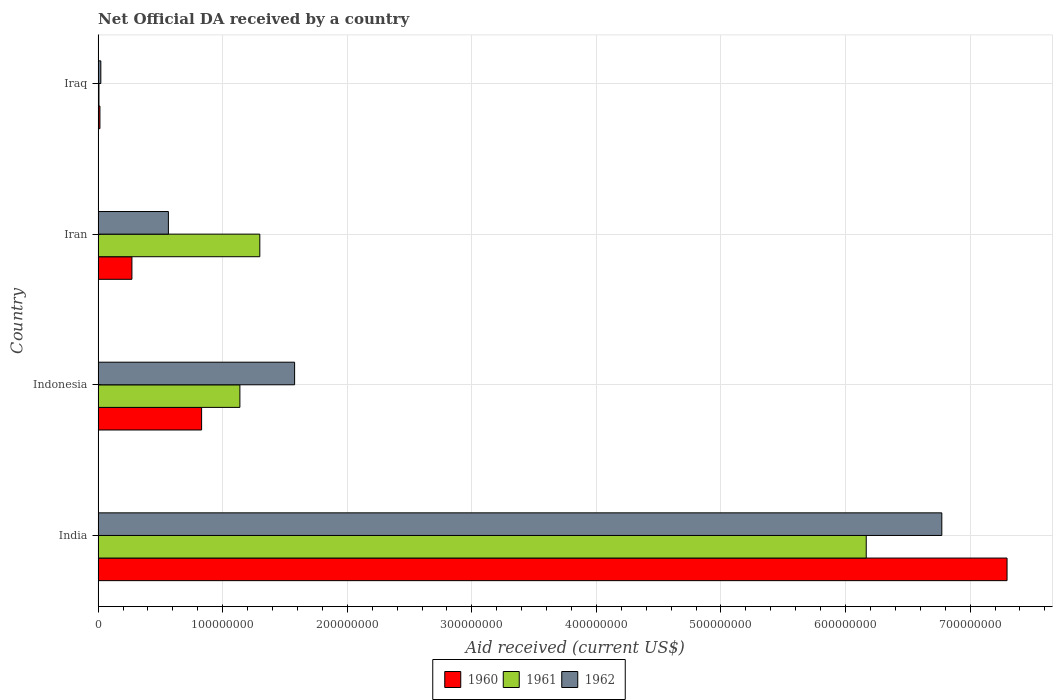How many groups of bars are there?
Offer a terse response. 4. How many bars are there on the 4th tick from the top?
Keep it short and to the point. 3. How many bars are there on the 2nd tick from the bottom?
Provide a succinct answer. 3. What is the label of the 2nd group of bars from the top?
Provide a short and direct response. Iran. What is the net official development assistance aid received in 1962 in Indonesia?
Provide a short and direct response. 1.58e+08. Across all countries, what is the maximum net official development assistance aid received in 1962?
Provide a short and direct response. 6.77e+08. Across all countries, what is the minimum net official development assistance aid received in 1961?
Your response must be concise. 6.80e+05. In which country was the net official development assistance aid received in 1961 minimum?
Offer a terse response. Iraq. What is the total net official development assistance aid received in 1960 in the graph?
Your answer should be compact. 8.41e+08. What is the difference between the net official development assistance aid received in 1961 in Indonesia and that in Iraq?
Keep it short and to the point. 1.13e+08. What is the difference between the net official development assistance aid received in 1960 in Iraq and the net official development assistance aid received in 1962 in Indonesia?
Ensure brevity in your answer.  -1.56e+08. What is the average net official development assistance aid received in 1960 per country?
Provide a short and direct response. 2.10e+08. What is the difference between the net official development assistance aid received in 1962 and net official development assistance aid received in 1961 in Indonesia?
Your answer should be compact. 4.39e+07. In how many countries, is the net official development assistance aid received in 1961 greater than 360000000 US$?
Your answer should be compact. 1. What is the ratio of the net official development assistance aid received in 1960 in Iran to that in Iraq?
Keep it short and to the point. 18.71. Is the net official development assistance aid received in 1961 in India less than that in Indonesia?
Your answer should be very brief. No. What is the difference between the highest and the second highest net official development assistance aid received in 1962?
Provide a short and direct response. 5.20e+08. What is the difference between the highest and the lowest net official development assistance aid received in 1961?
Your answer should be compact. 6.16e+08. What does the 1st bar from the bottom in Iraq represents?
Give a very brief answer. 1960. How many bars are there?
Offer a very short reply. 12. How many countries are there in the graph?
Give a very brief answer. 4. What is the difference between two consecutive major ticks on the X-axis?
Make the answer very short. 1.00e+08. Are the values on the major ticks of X-axis written in scientific E-notation?
Your response must be concise. No. Does the graph contain any zero values?
Make the answer very short. No. Where does the legend appear in the graph?
Make the answer very short. Bottom center. How are the legend labels stacked?
Your response must be concise. Horizontal. What is the title of the graph?
Keep it short and to the point. Net Official DA received by a country. Does "1997" appear as one of the legend labels in the graph?
Your answer should be very brief. No. What is the label or title of the X-axis?
Ensure brevity in your answer.  Aid received (current US$). What is the label or title of the Y-axis?
Offer a very short reply. Country. What is the Aid received (current US$) in 1960 in India?
Your answer should be very brief. 7.30e+08. What is the Aid received (current US$) of 1961 in India?
Keep it short and to the point. 6.17e+08. What is the Aid received (current US$) of 1962 in India?
Your answer should be compact. 6.77e+08. What is the Aid received (current US$) in 1960 in Indonesia?
Ensure brevity in your answer.  8.31e+07. What is the Aid received (current US$) in 1961 in Indonesia?
Offer a very short reply. 1.14e+08. What is the Aid received (current US$) of 1962 in Indonesia?
Your response must be concise. 1.58e+08. What is the Aid received (current US$) in 1960 in Iran?
Make the answer very short. 2.71e+07. What is the Aid received (current US$) in 1961 in Iran?
Provide a short and direct response. 1.30e+08. What is the Aid received (current US$) in 1962 in Iran?
Give a very brief answer. 5.64e+07. What is the Aid received (current US$) of 1960 in Iraq?
Make the answer very short. 1.45e+06. What is the Aid received (current US$) in 1961 in Iraq?
Your answer should be compact. 6.80e+05. What is the Aid received (current US$) of 1962 in Iraq?
Make the answer very short. 2.18e+06. Across all countries, what is the maximum Aid received (current US$) of 1960?
Keep it short and to the point. 7.30e+08. Across all countries, what is the maximum Aid received (current US$) in 1961?
Give a very brief answer. 6.17e+08. Across all countries, what is the maximum Aid received (current US$) of 1962?
Give a very brief answer. 6.77e+08. Across all countries, what is the minimum Aid received (current US$) of 1960?
Ensure brevity in your answer.  1.45e+06. Across all countries, what is the minimum Aid received (current US$) in 1961?
Offer a terse response. 6.80e+05. Across all countries, what is the minimum Aid received (current US$) in 1962?
Keep it short and to the point. 2.18e+06. What is the total Aid received (current US$) of 1960 in the graph?
Give a very brief answer. 8.41e+08. What is the total Aid received (current US$) in 1961 in the graph?
Keep it short and to the point. 8.61e+08. What is the total Aid received (current US$) in 1962 in the graph?
Your answer should be very brief. 8.94e+08. What is the difference between the Aid received (current US$) in 1960 in India and that in Indonesia?
Offer a terse response. 6.47e+08. What is the difference between the Aid received (current US$) in 1961 in India and that in Indonesia?
Your answer should be compact. 5.03e+08. What is the difference between the Aid received (current US$) of 1962 in India and that in Indonesia?
Make the answer very short. 5.20e+08. What is the difference between the Aid received (current US$) in 1960 in India and that in Iran?
Provide a short and direct response. 7.02e+08. What is the difference between the Aid received (current US$) in 1961 in India and that in Iran?
Provide a short and direct response. 4.87e+08. What is the difference between the Aid received (current US$) in 1962 in India and that in Iran?
Offer a very short reply. 6.21e+08. What is the difference between the Aid received (current US$) in 1960 in India and that in Iraq?
Make the answer very short. 7.28e+08. What is the difference between the Aid received (current US$) of 1961 in India and that in Iraq?
Make the answer very short. 6.16e+08. What is the difference between the Aid received (current US$) of 1962 in India and that in Iraq?
Offer a terse response. 6.75e+08. What is the difference between the Aid received (current US$) of 1960 in Indonesia and that in Iran?
Give a very brief answer. 5.60e+07. What is the difference between the Aid received (current US$) of 1961 in Indonesia and that in Iran?
Provide a succinct answer. -1.60e+07. What is the difference between the Aid received (current US$) of 1962 in Indonesia and that in Iran?
Your answer should be very brief. 1.01e+08. What is the difference between the Aid received (current US$) of 1960 in Indonesia and that in Iraq?
Provide a succinct answer. 8.16e+07. What is the difference between the Aid received (current US$) in 1961 in Indonesia and that in Iraq?
Keep it short and to the point. 1.13e+08. What is the difference between the Aid received (current US$) in 1962 in Indonesia and that in Iraq?
Provide a short and direct response. 1.56e+08. What is the difference between the Aid received (current US$) in 1960 in Iran and that in Iraq?
Provide a succinct answer. 2.57e+07. What is the difference between the Aid received (current US$) in 1961 in Iran and that in Iraq?
Provide a succinct answer. 1.29e+08. What is the difference between the Aid received (current US$) of 1962 in Iran and that in Iraq?
Provide a short and direct response. 5.42e+07. What is the difference between the Aid received (current US$) in 1960 in India and the Aid received (current US$) in 1961 in Indonesia?
Provide a short and direct response. 6.16e+08. What is the difference between the Aid received (current US$) of 1960 in India and the Aid received (current US$) of 1962 in Indonesia?
Provide a succinct answer. 5.72e+08. What is the difference between the Aid received (current US$) in 1961 in India and the Aid received (current US$) in 1962 in Indonesia?
Offer a very short reply. 4.59e+08. What is the difference between the Aid received (current US$) of 1960 in India and the Aid received (current US$) of 1961 in Iran?
Offer a terse response. 6.00e+08. What is the difference between the Aid received (current US$) of 1960 in India and the Aid received (current US$) of 1962 in Iran?
Your response must be concise. 6.73e+08. What is the difference between the Aid received (current US$) of 1961 in India and the Aid received (current US$) of 1962 in Iran?
Your response must be concise. 5.60e+08. What is the difference between the Aid received (current US$) of 1960 in India and the Aid received (current US$) of 1961 in Iraq?
Provide a succinct answer. 7.29e+08. What is the difference between the Aid received (current US$) of 1960 in India and the Aid received (current US$) of 1962 in Iraq?
Provide a succinct answer. 7.27e+08. What is the difference between the Aid received (current US$) of 1961 in India and the Aid received (current US$) of 1962 in Iraq?
Keep it short and to the point. 6.14e+08. What is the difference between the Aid received (current US$) of 1960 in Indonesia and the Aid received (current US$) of 1961 in Iran?
Your answer should be compact. -4.67e+07. What is the difference between the Aid received (current US$) in 1960 in Indonesia and the Aid received (current US$) in 1962 in Iran?
Offer a very short reply. 2.67e+07. What is the difference between the Aid received (current US$) of 1961 in Indonesia and the Aid received (current US$) of 1962 in Iran?
Give a very brief answer. 5.74e+07. What is the difference between the Aid received (current US$) of 1960 in Indonesia and the Aid received (current US$) of 1961 in Iraq?
Give a very brief answer. 8.24e+07. What is the difference between the Aid received (current US$) in 1960 in Indonesia and the Aid received (current US$) in 1962 in Iraq?
Give a very brief answer. 8.09e+07. What is the difference between the Aid received (current US$) in 1961 in Indonesia and the Aid received (current US$) in 1962 in Iraq?
Make the answer very short. 1.12e+08. What is the difference between the Aid received (current US$) of 1960 in Iran and the Aid received (current US$) of 1961 in Iraq?
Your answer should be compact. 2.64e+07. What is the difference between the Aid received (current US$) of 1960 in Iran and the Aid received (current US$) of 1962 in Iraq?
Your response must be concise. 2.50e+07. What is the difference between the Aid received (current US$) of 1961 in Iran and the Aid received (current US$) of 1962 in Iraq?
Offer a very short reply. 1.28e+08. What is the average Aid received (current US$) of 1960 per country?
Your answer should be compact. 2.10e+08. What is the average Aid received (current US$) of 1961 per country?
Give a very brief answer. 2.15e+08. What is the average Aid received (current US$) in 1962 per country?
Give a very brief answer. 2.23e+08. What is the difference between the Aid received (current US$) in 1960 and Aid received (current US$) in 1961 in India?
Provide a succinct answer. 1.13e+08. What is the difference between the Aid received (current US$) in 1960 and Aid received (current US$) in 1962 in India?
Keep it short and to the point. 5.24e+07. What is the difference between the Aid received (current US$) in 1961 and Aid received (current US$) in 1962 in India?
Provide a short and direct response. -6.07e+07. What is the difference between the Aid received (current US$) of 1960 and Aid received (current US$) of 1961 in Indonesia?
Offer a terse response. -3.07e+07. What is the difference between the Aid received (current US$) in 1960 and Aid received (current US$) in 1962 in Indonesia?
Your answer should be very brief. -7.46e+07. What is the difference between the Aid received (current US$) of 1961 and Aid received (current US$) of 1962 in Indonesia?
Your answer should be compact. -4.39e+07. What is the difference between the Aid received (current US$) of 1960 and Aid received (current US$) of 1961 in Iran?
Give a very brief answer. -1.03e+08. What is the difference between the Aid received (current US$) of 1960 and Aid received (current US$) of 1962 in Iran?
Your answer should be very brief. -2.93e+07. What is the difference between the Aid received (current US$) of 1961 and Aid received (current US$) of 1962 in Iran?
Keep it short and to the point. 7.34e+07. What is the difference between the Aid received (current US$) of 1960 and Aid received (current US$) of 1961 in Iraq?
Ensure brevity in your answer.  7.70e+05. What is the difference between the Aid received (current US$) of 1960 and Aid received (current US$) of 1962 in Iraq?
Provide a succinct answer. -7.30e+05. What is the difference between the Aid received (current US$) of 1961 and Aid received (current US$) of 1962 in Iraq?
Provide a short and direct response. -1.50e+06. What is the ratio of the Aid received (current US$) in 1960 in India to that in Indonesia?
Your answer should be compact. 8.78. What is the ratio of the Aid received (current US$) in 1961 in India to that in Indonesia?
Your answer should be very brief. 5.42. What is the ratio of the Aid received (current US$) in 1962 in India to that in Indonesia?
Provide a short and direct response. 4.29. What is the ratio of the Aid received (current US$) in 1960 in India to that in Iran?
Make the answer very short. 26.89. What is the ratio of the Aid received (current US$) in 1961 in India to that in Iran?
Give a very brief answer. 4.75. What is the ratio of the Aid received (current US$) in 1962 in India to that in Iran?
Your answer should be very brief. 12.01. What is the ratio of the Aid received (current US$) of 1960 in India to that in Iraq?
Your response must be concise. 503.19. What is the ratio of the Aid received (current US$) in 1961 in India to that in Iraq?
Keep it short and to the point. 906.75. What is the ratio of the Aid received (current US$) of 1962 in India to that in Iraq?
Provide a short and direct response. 310.67. What is the ratio of the Aid received (current US$) of 1960 in Indonesia to that in Iran?
Your answer should be very brief. 3.06. What is the ratio of the Aid received (current US$) of 1961 in Indonesia to that in Iran?
Provide a succinct answer. 0.88. What is the ratio of the Aid received (current US$) in 1962 in Indonesia to that in Iran?
Your response must be concise. 2.8. What is the ratio of the Aid received (current US$) of 1960 in Indonesia to that in Iraq?
Give a very brief answer. 57.3. What is the ratio of the Aid received (current US$) in 1961 in Indonesia to that in Iraq?
Your response must be concise. 167.35. What is the ratio of the Aid received (current US$) of 1962 in Indonesia to that in Iraq?
Give a very brief answer. 72.35. What is the ratio of the Aid received (current US$) in 1960 in Iran to that in Iraq?
Your answer should be compact. 18.71. What is the ratio of the Aid received (current US$) of 1961 in Iran to that in Iraq?
Give a very brief answer. 190.88. What is the ratio of the Aid received (current US$) of 1962 in Iran to that in Iraq?
Your answer should be very brief. 25.88. What is the difference between the highest and the second highest Aid received (current US$) in 1960?
Provide a succinct answer. 6.47e+08. What is the difference between the highest and the second highest Aid received (current US$) in 1961?
Offer a very short reply. 4.87e+08. What is the difference between the highest and the second highest Aid received (current US$) in 1962?
Offer a terse response. 5.20e+08. What is the difference between the highest and the lowest Aid received (current US$) of 1960?
Give a very brief answer. 7.28e+08. What is the difference between the highest and the lowest Aid received (current US$) in 1961?
Your answer should be very brief. 6.16e+08. What is the difference between the highest and the lowest Aid received (current US$) of 1962?
Make the answer very short. 6.75e+08. 